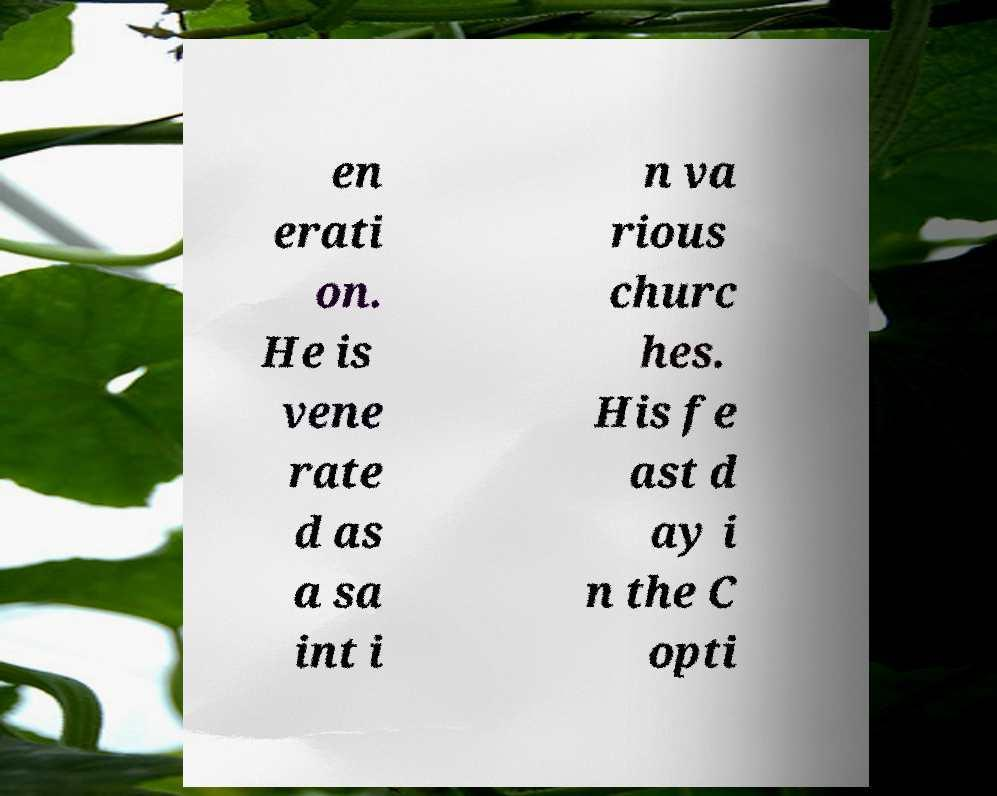Can you accurately transcribe the text from the provided image for me? en erati on. He is vene rate d as a sa int i n va rious churc hes. His fe ast d ay i n the C opti 